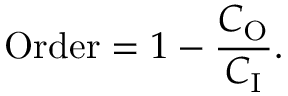Convert formula to latex. <formula><loc_0><loc_0><loc_500><loc_500>{ O r d e r } = 1 - { \frac { C _ { O } } { C _ { I } } } .</formula> 